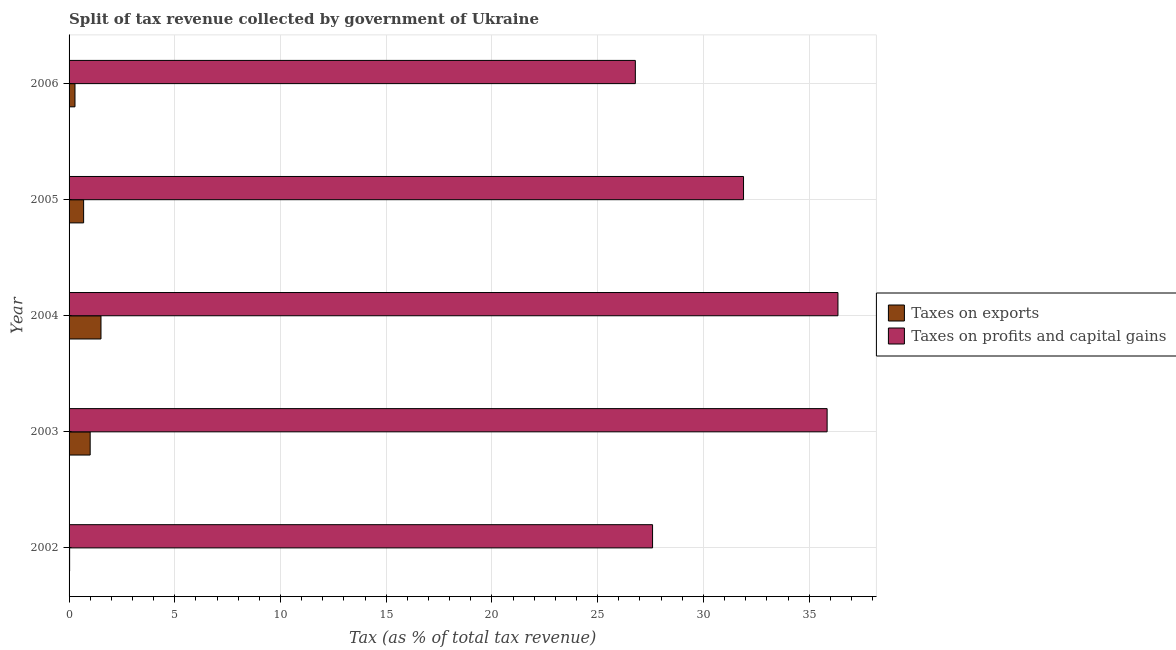How many groups of bars are there?
Your answer should be compact. 5. Are the number of bars per tick equal to the number of legend labels?
Give a very brief answer. Yes. How many bars are there on the 2nd tick from the bottom?
Provide a succinct answer. 2. What is the label of the 1st group of bars from the top?
Your answer should be compact. 2006. What is the percentage of revenue obtained from taxes on exports in 2006?
Give a very brief answer. 0.28. Across all years, what is the maximum percentage of revenue obtained from taxes on profits and capital gains?
Make the answer very short. 36.36. Across all years, what is the minimum percentage of revenue obtained from taxes on profits and capital gains?
Your answer should be compact. 26.78. In which year was the percentage of revenue obtained from taxes on exports maximum?
Provide a succinct answer. 2004. In which year was the percentage of revenue obtained from taxes on profits and capital gains minimum?
Your answer should be compact. 2006. What is the total percentage of revenue obtained from taxes on exports in the graph?
Provide a succinct answer. 3.5. What is the difference between the percentage of revenue obtained from taxes on profits and capital gains in 2002 and that in 2006?
Give a very brief answer. 0.81. What is the difference between the percentage of revenue obtained from taxes on exports in 2006 and the percentage of revenue obtained from taxes on profits and capital gains in 2005?
Give a very brief answer. -31.62. What is the average percentage of revenue obtained from taxes on profits and capital gains per year?
Your answer should be compact. 31.7. In the year 2006, what is the difference between the percentage of revenue obtained from taxes on exports and percentage of revenue obtained from taxes on profits and capital gains?
Give a very brief answer. -26.5. In how many years, is the percentage of revenue obtained from taxes on exports greater than 10 %?
Give a very brief answer. 0. What is the ratio of the percentage of revenue obtained from taxes on exports in 2004 to that in 2005?
Offer a terse response. 2.19. Is the difference between the percentage of revenue obtained from taxes on profits and capital gains in 2004 and 2006 greater than the difference between the percentage of revenue obtained from taxes on exports in 2004 and 2006?
Provide a succinct answer. Yes. What is the difference between the highest and the second highest percentage of revenue obtained from taxes on exports?
Provide a succinct answer. 0.51. What is the difference between the highest and the lowest percentage of revenue obtained from taxes on profits and capital gains?
Your answer should be very brief. 9.58. Is the sum of the percentage of revenue obtained from taxes on profits and capital gains in 2003 and 2006 greater than the maximum percentage of revenue obtained from taxes on exports across all years?
Make the answer very short. Yes. What does the 2nd bar from the top in 2003 represents?
Offer a very short reply. Taxes on exports. What does the 2nd bar from the bottom in 2003 represents?
Your answer should be very brief. Taxes on profits and capital gains. How many bars are there?
Keep it short and to the point. 10. Are all the bars in the graph horizontal?
Keep it short and to the point. Yes. Does the graph contain any zero values?
Your answer should be compact. No. How many legend labels are there?
Your response must be concise. 2. What is the title of the graph?
Your answer should be very brief. Split of tax revenue collected by government of Ukraine. What is the label or title of the X-axis?
Your response must be concise. Tax (as % of total tax revenue). What is the Tax (as % of total tax revenue) in Taxes on exports in 2002?
Your response must be concise. 0.03. What is the Tax (as % of total tax revenue) of Taxes on profits and capital gains in 2002?
Make the answer very short. 27.59. What is the Tax (as % of total tax revenue) in Taxes on exports in 2003?
Your response must be concise. 1. What is the Tax (as % of total tax revenue) of Taxes on profits and capital gains in 2003?
Offer a very short reply. 35.85. What is the Tax (as % of total tax revenue) of Taxes on exports in 2004?
Make the answer very short. 1.51. What is the Tax (as % of total tax revenue) in Taxes on profits and capital gains in 2004?
Provide a succinct answer. 36.36. What is the Tax (as % of total tax revenue) in Taxes on exports in 2005?
Ensure brevity in your answer.  0.69. What is the Tax (as % of total tax revenue) in Taxes on profits and capital gains in 2005?
Keep it short and to the point. 31.9. What is the Tax (as % of total tax revenue) in Taxes on exports in 2006?
Your response must be concise. 0.28. What is the Tax (as % of total tax revenue) of Taxes on profits and capital gains in 2006?
Provide a short and direct response. 26.78. Across all years, what is the maximum Tax (as % of total tax revenue) of Taxes on exports?
Offer a terse response. 1.51. Across all years, what is the maximum Tax (as % of total tax revenue) of Taxes on profits and capital gains?
Offer a very short reply. 36.36. Across all years, what is the minimum Tax (as % of total tax revenue) of Taxes on exports?
Ensure brevity in your answer.  0.03. Across all years, what is the minimum Tax (as % of total tax revenue) in Taxes on profits and capital gains?
Provide a succinct answer. 26.78. What is the total Tax (as % of total tax revenue) of Taxes on exports in the graph?
Provide a succinct answer. 3.5. What is the total Tax (as % of total tax revenue) of Taxes on profits and capital gains in the graph?
Your response must be concise. 158.48. What is the difference between the Tax (as % of total tax revenue) in Taxes on exports in 2002 and that in 2003?
Offer a terse response. -0.97. What is the difference between the Tax (as % of total tax revenue) of Taxes on profits and capital gains in 2002 and that in 2003?
Keep it short and to the point. -8.26. What is the difference between the Tax (as % of total tax revenue) of Taxes on exports in 2002 and that in 2004?
Give a very brief answer. -1.48. What is the difference between the Tax (as % of total tax revenue) in Taxes on profits and capital gains in 2002 and that in 2004?
Provide a succinct answer. -8.77. What is the difference between the Tax (as % of total tax revenue) in Taxes on exports in 2002 and that in 2005?
Offer a very short reply. -0.66. What is the difference between the Tax (as % of total tax revenue) of Taxes on profits and capital gains in 2002 and that in 2005?
Make the answer very short. -4.3. What is the difference between the Tax (as % of total tax revenue) of Taxes on exports in 2002 and that in 2006?
Keep it short and to the point. -0.25. What is the difference between the Tax (as % of total tax revenue) of Taxes on profits and capital gains in 2002 and that in 2006?
Ensure brevity in your answer.  0.81. What is the difference between the Tax (as % of total tax revenue) of Taxes on exports in 2003 and that in 2004?
Your answer should be very brief. -0.51. What is the difference between the Tax (as % of total tax revenue) in Taxes on profits and capital gains in 2003 and that in 2004?
Provide a succinct answer. -0.51. What is the difference between the Tax (as % of total tax revenue) in Taxes on exports in 2003 and that in 2005?
Provide a short and direct response. 0.31. What is the difference between the Tax (as % of total tax revenue) of Taxes on profits and capital gains in 2003 and that in 2005?
Keep it short and to the point. 3.95. What is the difference between the Tax (as % of total tax revenue) of Taxes on exports in 2003 and that in 2006?
Your response must be concise. 0.72. What is the difference between the Tax (as % of total tax revenue) of Taxes on profits and capital gains in 2003 and that in 2006?
Provide a succinct answer. 9.07. What is the difference between the Tax (as % of total tax revenue) of Taxes on exports in 2004 and that in 2005?
Offer a terse response. 0.82. What is the difference between the Tax (as % of total tax revenue) of Taxes on profits and capital gains in 2004 and that in 2005?
Offer a very short reply. 4.47. What is the difference between the Tax (as % of total tax revenue) in Taxes on exports in 2004 and that in 2006?
Provide a succinct answer. 1.23. What is the difference between the Tax (as % of total tax revenue) in Taxes on profits and capital gains in 2004 and that in 2006?
Keep it short and to the point. 9.58. What is the difference between the Tax (as % of total tax revenue) in Taxes on exports in 2005 and that in 2006?
Offer a terse response. 0.41. What is the difference between the Tax (as % of total tax revenue) in Taxes on profits and capital gains in 2005 and that in 2006?
Offer a terse response. 5.12. What is the difference between the Tax (as % of total tax revenue) of Taxes on exports in 2002 and the Tax (as % of total tax revenue) of Taxes on profits and capital gains in 2003?
Give a very brief answer. -35.82. What is the difference between the Tax (as % of total tax revenue) in Taxes on exports in 2002 and the Tax (as % of total tax revenue) in Taxes on profits and capital gains in 2004?
Ensure brevity in your answer.  -36.34. What is the difference between the Tax (as % of total tax revenue) of Taxes on exports in 2002 and the Tax (as % of total tax revenue) of Taxes on profits and capital gains in 2005?
Your response must be concise. -31.87. What is the difference between the Tax (as % of total tax revenue) of Taxes on exports in 2002 and the Tax (as % of total tax revenue) of Taxes on profits and capital gains in 2006?
Give a very brief answer. -26.75. What is the difference between the Tax (as % of total tax revenue) of Taxes on exports in 2003 and the Tax (as % of total tax revenue) of Taxes on profits and capital gains in 2004?
Your response must be concise. -35.36. What is the difference between the Tax (as % of total tax revenue) of Taxes on exports in 2003 and the Tax (as % of total tax revenue) of Taxes on profits and capital gains in 2005?
Your answer should be very brief. -30.9. What is the difference between the Tax (as % of total tax revenue) of Taxes on exports in 2003 and the Tax (as % of total tax revenue) of Taxes on profits and capital gains in 2006?
Make the answer very short. -25.78. What is the difference between the Tax (as % of total tax revenue) in Taxes on exports in 2004 and the Tax (as % of total tax revenue) in Taxes on profits and capital gains in 2005?
Ensure brevity in your answer.  -30.39. What is the difference between the Tax (as % of total tax revenue) in Taxes on exports in 2004 and the Tax (as % of total tax revenue) in Taxes on profits and capital gains in 2006?
Keep it short and to the point. -25.27. What is the difference between the Tax (as % of total tax revenue) in Taxes on exports in 2005 and the Tax (as % of total tax revenue) in Taxes on profits and capital gains in 2006?
Make the answer very short. -26.09. What is the average Tax (as % of total tax revenue) in Taxes on exports per year?
Make the answer very short. 0.7. What is the average Tax (as % of total tax revenue) of Taxes on profits and capital gains per year?
Your answer should be compact. 31.7. In the year 2002, what is the difference between the Tax (as % of total tax revenue) of Taxes on exports and Tax (as % of total tax revenue) of Taxes on profits and capital gains?
Your answer should be compact. -27.57. In the year 2003, what is the difference between the Tax (as % of total tax revenue) in Taxes on exports and Tax (as % of total tax revenue) in Taxes on profits and capital gains?
Your answer should be compact. -34.85. In the year 2004, what is the difference between the Tax (as % of total tax revenue) in Taxes on exports and Tax (as % of total tax revenue) in Taxes on profits and capital gains?
Your response must be concise. -34.85. In the year 2005, what is the difference between the Tax (as % of total tax revenue) of Taxes on exports and Tax (as % of total tax revenue) of Taxes on profits and capital gains?
Offer a terse response. -31.21. In the year 2006, what is the difference between the Tax (as % of total tax revenue) in Taxes on exports and Tax (as % of total tax revenue) in Taxes on profits and capital gains?
Offer a terse response. -26.5. What is the ratio of the Tax (as % of total tax revenue) of Taxes on exports in 2002 to that in 2003?
Offer a terse response. 0.03. What is the ratio of the Tax (as % of total tax revenue) of Taxes on profits and capital gains in 2002 to that in 2003?
Make the answer very short. 0.77. What is the ratio of the Tax (as % of total tax revenue) of Taxes on exports in 2002 to that in 2004?
Provide a short and direct response. 0.02. What is the ratio of the Tax (as % of total tax revenue) in Taxes on profits and capital gains in 2002 to that in 2004?
Ensure brevity in your answer.  0.76. What is the ratio of the Tax (as % of total tax revenue) of Taxes on exports in 2002 to that in 2005?
Your answer should be compact. 0.04. What is the ratio of the Tax (as % of total tax revenue) in Taxes on profits and capital gains in 2002 to that in 2005?
Provide a short and direct response. 0.87. What is the ratio of the Tax (as % of total tax revenue) of Taxes on exports in 2002 to that in 2006?
Offer a very short reply. 0.09. What is the ratio of the Tax (as % of total tax revenue) of Taxes on profits and capital gains in 2002 to that in 2006?
Ensure brevity in your answer.  1.03. What is the ratio of the Tax (as % of total tax revenue) in Taxes on exports in 2003 to that in 2004?
Keep it short and to the point. 0.66. What is the ratio of the Tax (as % of total tax revenue) of Taxes on profits and capital gains in 2003 to that in 2004?
Offer a terse response. 0.99. What is the ratio of the Tax (as % of total tax revenue) in Taxes on exports in 2003 to that in 2005?
Provide a succinct answer. 1.45. What is the ratio of the Tax (as % of total tax revenue) of Taxes on profits and capital gains in 2003 to that in 2005?
Keep it short and to the point. 1.12. What is the ratio of the Tax (as % of total tax revenue) in Taxes on exports in 2003 to that in 2006?
Provide a short and direct response. 3.57. What is the ratio of the Tax (as % of total tax revenue) in Taxes on profits and capital gains in 2003 to that in 2006?
Provide a succinct answer. 1.34. What is the ratio of the Tax (as % of total tax revenue) of Taxes on exports in 2004 to that in 2005?
Ensure brevity in your answer.  2.19. What is the ratio of the Tax (as % of total tax revenue) of Taxes on profits and capital gains in 2004 to that in 2005?
Ensure brevity in your answer.  1.14. What is the ratio of the Tax (as % of total tax revenue) of Taxes on exports in 2004 to that in 2006?
Ensure brevity in your answer.  5.4. What is the ratio of the Tax (as % of total tax revenue) of Taxes on profits and capital gains in 2004 to that in 2006?
Give a very brief answer. 1.36. What is the ratio of the Tax (as % of total tax revenue) in Taxes on exports in 2005 to that in 2006?
Keep it short and to the point. 2.46. What is the ratio of the Tax (as % of total tax revenue) of Taxes on profits and capital gains in 2005 to that in 2006?
Keep it short and to the point. 1.19. What is the difference between the highest and the second highest Tax (as % of total tax revenue) of Taxes on exports?
Provide a succinct answer. 0.51. What is the difference between the highest and the second highest Tax (as % of total tax revenue) of Taxes on profits and capital gains?
Give a very brief answer. 0.51. What is the difference between the highest and the lowest Tax (as % of total tax revenue) in Taxes on exports?
Offer a terse response. 1.48. What is the difference between the highest and the lowest Tax (as % of total tax revenue) of Taxes on profits and capital gains?
Provide a short and direct response. 9.58. 